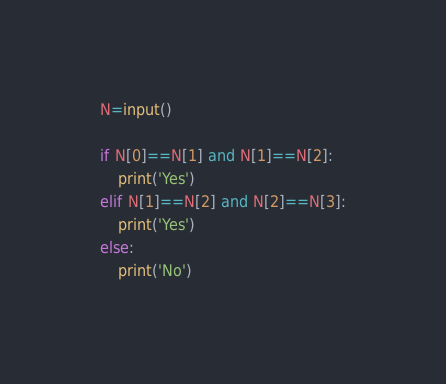<code> <loc_0><loc_0><loc_500><loc_500><_Python_>N=input()

if N[0]==N[1] and N[1]==N[2]:
    print('Yes')
elif N[1]==N[2] and N[2]==N[3]:
    print('Yes')
else:
    print('No')</code> 